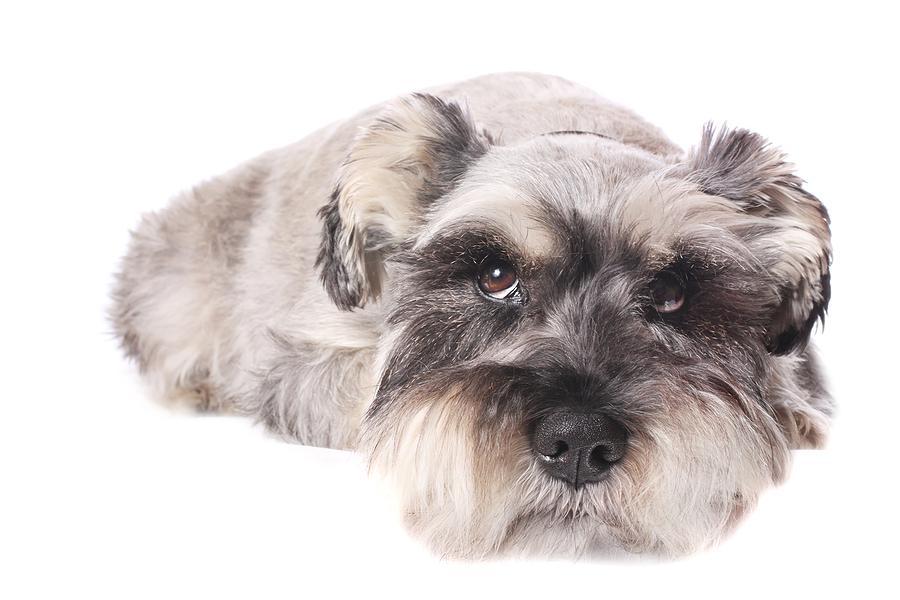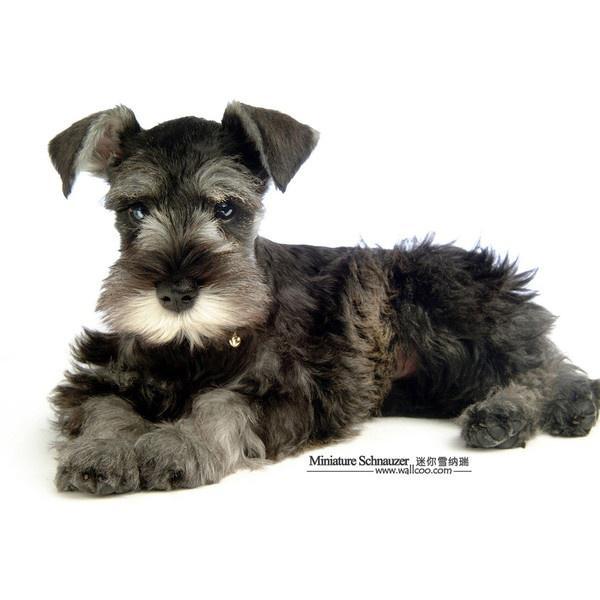The first image is the image on the left, the second image is the image on the right. Analyze the images presented: Is the assertion "There are two dogs, both lying down." valid? Answer yes or no. Yes. The first image is the image on the left, the second image is the image on the right. Analyze the images presented: Is the assertion "Each image contains the same number of dogs, and the dogs in both images are posed similarly." valid? Answer yes or no. No. 